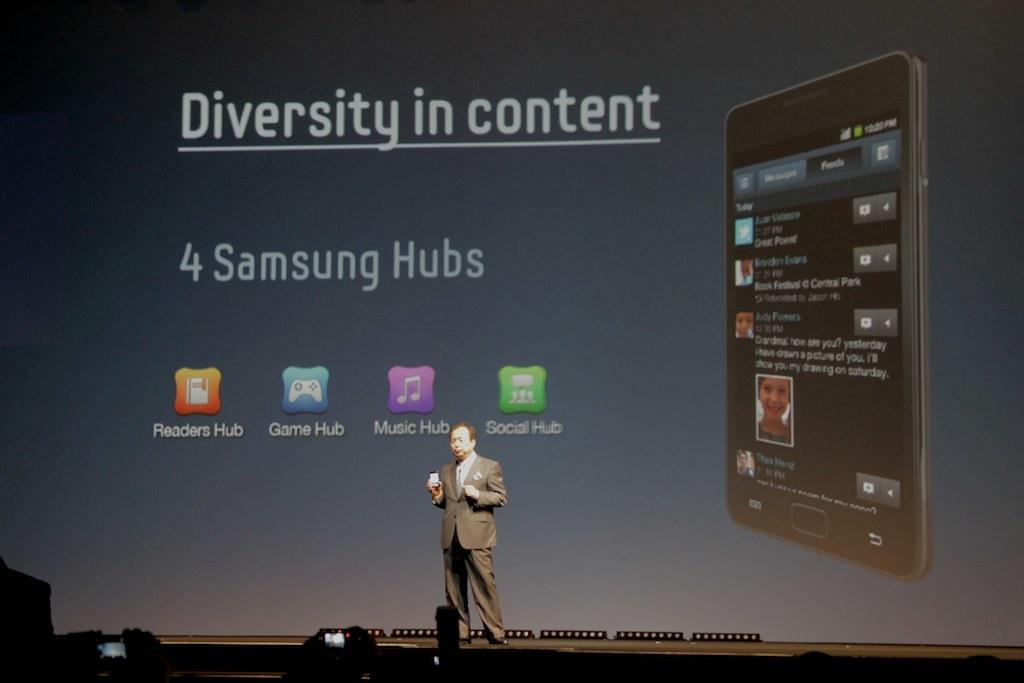<image>
Give a short and clear explanation of the subsequent image. a man giving speech over Samsung phone background 